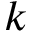<formula> <loc_0><loc_0><loc_500><loc_500>k</formula> 